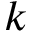<formula> <loc_0><loc_0><loc_500><loc_500>k</formula> 